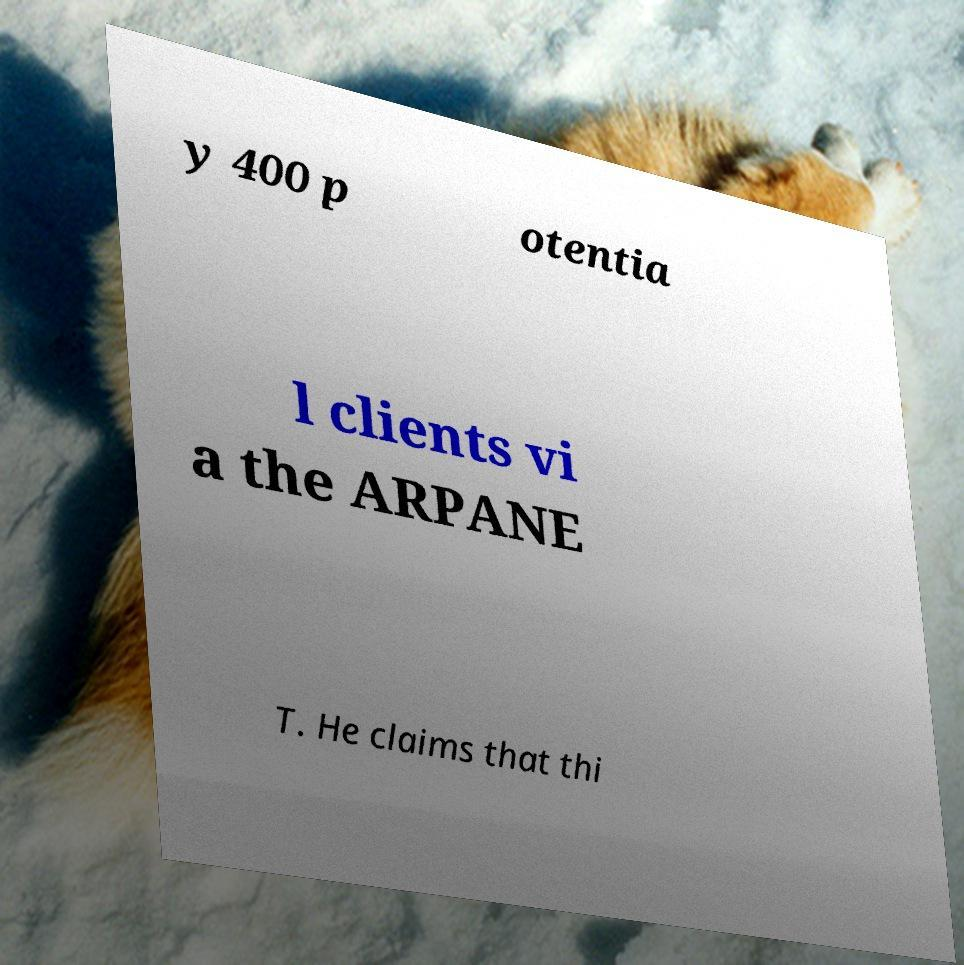Please identify and transcribe the text found in this image. y 400 p otentia l clients vi a the ARPANE T. He claims that thi 